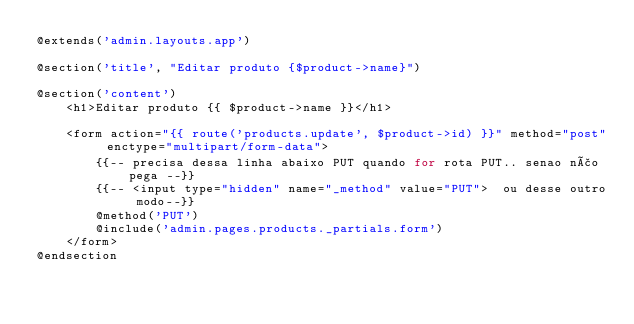Convert code to text. <code><loc_0><loc_0><loc_500><loc_500><_PHP_>@extends('admin.layouts.app')

@section('title', "Editar produto {$product->name}")

@section('content')
    <h1>Editar produto {{ $product->name }}</h1>

    <form action="{{ route('products.update', $product->id) }}" method="post" enctype="multipart/form-data">
        {{-- precisa dessa linha abaixo PUT quando for rota PUT.. senao não pega --}}
        {{-- <input type="hidden" name="_method" value="PUT">  ou desse outro modo--}}
        @method('PUT')
        @include('admin.pages.products._partials.form')
    </form>
@endsection</code> 